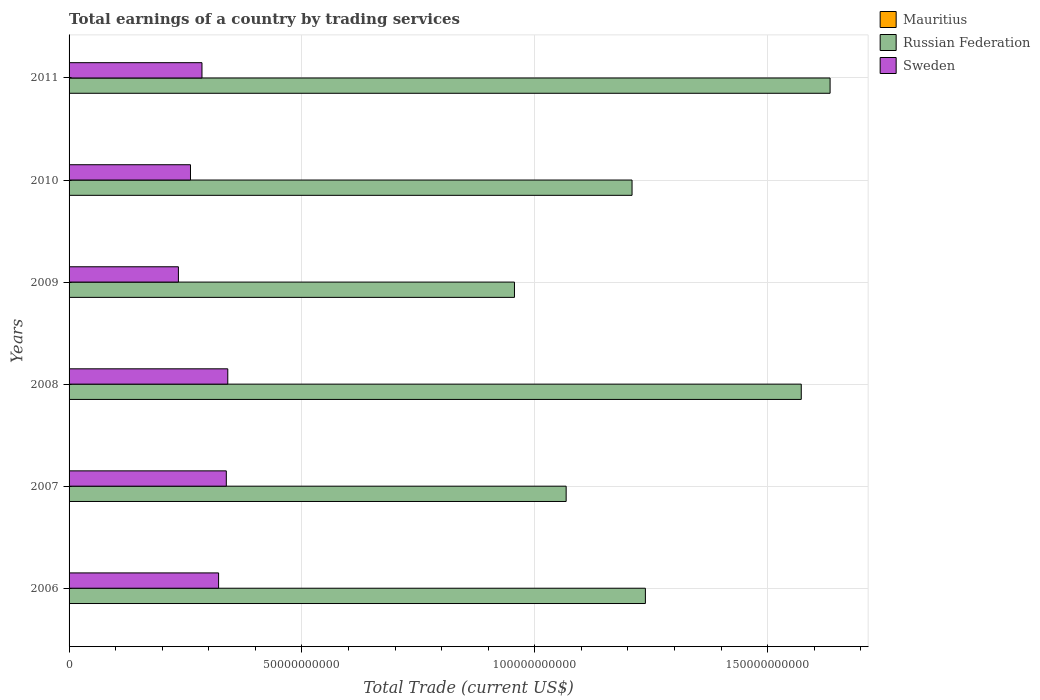How many bars are there on the 3rd tick from the top?
Your answer should be very brief. 2. What is the label of the 4th group of bars from the top?
Provide a succinct answer. 2008. What is the total earnings in Mauritius in 2006?
Make the answer very short. 0. Across all years, what is the maximum total earnings in Sweden?
Keep it short and to the point. 3.41e+1. Across all years, what is the minimum total earnings in Sweden?
Give a very brief answer. 2.35e+1. In which year was the total earnings in Russian Federation maximum?
Your response must be concise. 2011. What is the total total earnings in Mauritius in the graph?
Ensure brevity in your answer.  0. What is the difference between the total earnings in Russian Federation in 2008 and that in 2009?
Ensure brevity in your answer.  6.16e+1. What is the difference between the total earnings in Sweden in 2010 and the total earnings in Russian Federation in 2009?
Provide a short and direct response. -6.96e+1. What is the average total earnings in Sweden per year?
Offer a very short reply. 2.97e+1. In the year 2009, what is the difference between the total earnings in Sweden and total earnings in Russian Federation?
Your response must be concise. -7.22e+1. What is the ratio of the total earnings in Russian Federation in 2008 to that in 2010?
Provide a short and direct response. 1.3. What is the difference between the highest and the second highest total earnings in Sweden?
Your answer should be very brief. 3.17e+08. What is the difference between the highest and the lowest total earnings in Sweden?
Ensure brevity in your answer.  1.06e+1. How many bars are there?
Make the answer very short. 12. How many years are there in the graph?
Offer a terse response. 6. What is the difference between two consecutive major ticks on the X-axis?
Offer a very short reply. 5.00e+1. Are the values on the major ticks of X-axis written in scientific E-notation?
Your answer should be very brief. No. Does the graph contain any zero values?
Ensure brevity in your answer.  Yes. Does the graph contain grids?
Offer a terse response. Yes. What is the title of the graph?
Your answer should be very brief. Total earnings of a country by trading services. What is the label or title of the X-axis?
Your answer should be compact. Total Trade (current US$). What is the Total Trade (current US$) in Russian Federation in 2006?
Keep it short and to the point. 1.24e+11. What is the Total Trade (current US$) in Sweden in 2006?
Make the answer very short. 3.21e+1. What is the Total Trade (current US$) of Mauritius in 2007?
Your response must be concise. 0. What is the Total Trade (current US$) in Russian Federation in 2007?
Make the answer very short. 1.07e+11. What is the Total Trade (current US$) in Sweden in 2007?
Provide a short and direct response. 3.38e+1. What is the Total Trade (current US$) in Mauritius in 2008?
Provide a succinct answer. 0. What is the Total Trade (current US$) in Russian Federation in 2008?
Give a very brief answer. 1.57e+11. What is the Total Trade (current US$) in Sweden in 2008?
Provide a succinct answer. 3.41e+1. What is the Total Trade (current US$) of Russian Federation in 2009?
Give a very brief answer. 9.56e+1. What is the Total Trade (current US$) of Sweden in 2009?
Your response must be concise. 2.35e+1. What is the Total Trade (current US$) in Russian Federation in 2010?
Offer a terse response. 1.21e+11. What is the Total Trade (current US$) of Sweden in 2010?
Provide a succinct answer. 2.61e+1. What is the Total Trade (current US$) in Mauritius in 2011?
Your answer should be very brief. 0. What is the Total Trade (current US$) of Russian Federation in 2011?
Ensure brevity in your answer.  1.63e+11. What is the Total Trade (current US$) in Sweden in 2011?
Offer a very short reply. 2.85e+1. Across all years, what is the maximum Total Trade (current US$) of Russian Federation?
Your answer should be very brief. 1.63e+11. Across all years, what is the maximum Total Trade (current US$) of Sweden?
Give a very brief answer. 3.41e+1. Across all years, what is the minimum Total Trade (current US$) of Russian Federation?
Keep it short and to the point. 9.56e+1. Across all years, what is the minimum Total Trade (current US$) in Sweden?
Make the answer very short. 2.35e+1. What is the total Total Trade (current US$) in Russian Federation in the graph?
Provide a short and direct response. 7.68e+11. What is the total Total Trade (current US$) of Sweden in the graph?
Provide a succinct answer. 1.78e+11. What is the difference between the Total Trade (current US$) in Russian Federation in 2006 and that in 2007?
Keep it short and to the point. 1.70e+1. What is the difference between the Total Trade (current US$) in Sweden in 2006 and that in 2007?
Your answer should be very brief. -1.66e+09. What is the difference between the Total Trade (current US$) in Russian Federation in 2006 and that in 2008?
Your answer should be compact. -3.35e+1. What is the difference between the Total Trade (current US$) in Sweden in 2006 and that in 2008?
Make the answer very short. -1.97e+09. What is the difference between the Total Trade (current US$) of Russian Federation in 2006 and that in 2009?
Your response must be concise. 2.81e+1. What is the difference between the Total Trade (current US$) of Sweden in 2006 and that in 2009?
Your response must be concise. 8.63e+09. What is the difference between the Total Trade (current US$) of Russian Federation in 2006 and that in 2010?
Keep it short and to the point. 2.86e+09. What is the difference between the Total Trade (current US$) of Sweden in 2006 and that in 2010?
Your answer should be very brief. 6.04e+09. What is the difference between the Total Trade (current US$) of Russian Federation in 2006 and that in 2011?
Your answer should be very brief. -3.97e+1. What is the difference between the Total Trade (current US$) in Sweden in 2006 and that in 2011?
Keep it short and to the point. 3.57e+09. What is the difference between the Total Trade (current US$) in Russian Federation in 2007 and that in 2008?
Make the answer very short. -5.05e+1. What is the difference between the Total Trade (current US$) in Sweden in 2007 and that in 2008?
Provide a short and direct response. -3.17e+08. What is the difference between the Total Trade (current US$) of Russian Federation in 2007 and that in 2009?
Provide a short and direct response. 1.11e+1. What is the difference between the Total Trade (current US$) in Sweden in 2007 and that in 2009?
Your response must be concise. 1.03e+1. What is the difference between the Total Trade (current US$) of Russian Federation in 2007 and that in 2010?
Give a very brief answer. -1.41e+1. What is the difference between the Total Trade (current US$) in Sweden in 2007 and that in 2010?
Provide a short and direct response. 7.69e+09. What is the difference between the Total Trade (current US$) in Russian Federation in 2007 and that in 2011?
Your response must be concise. -5.67e+1. What is the difference between the Total Trade (current US$) in Sweden in 2007 and that in 2011?
Provide a succinct answer. 5.23e+09. What is the difference between the Total Trade (current US$) of Russian Federation in 2008 and that in 2009?
Your answer should be very brief. 6.16e+1. What is the difference between the Total Trade (current US$) of Sweden in 2008 and that in 2009?
Your answer should be compact. 1.06e+1. What is the difference between the Total Trade (current US$) in Russian Federation in 2008 and that in 2010?
Provide a short and direct response. 3.63e+1. What is the difference between the Total Trade (current US$) in Sweden in 2008 and that in 2010?
Keep it short and to the point. 8.01e+09. What is the difference between the Total Trade (current US$) of Russian Federation in 2008 and that in 2011?
Ensure brevity in your answer.  -6.19e+09. What is the difference between the Total Trade (current US$) of Sweden in 2008 and that in 2011?
Keep it short and to the point. 5.54e+09. What is the difference between the Total Trade (current US$) of Russian Federation in 2009 and that in 2010?
Provide a short and direct response. -2.52e+1. What is the difference between the Total Trade (current US$) in Sweden in 2009 and that in 2010?
Your response must be concise. -2.59e+09. What is the difference between the Total Trade (current US$) in Russian Federation in 2009 and that in 2011?
Your response must be concise. -6.78e+1. What is the difference between the Total Trade (current US$) of Sweden in 2009 and that in 2011?
Your answer should be very brief. -5.06e+09. What is the difference between the Total Trade (current US$) in Russian Federation in 2010 and that in 2011?
Your answer should be compact. -4.25e+1. What is the difference between the Total Trade (current US$) of Sweden in 2010 and that in 2011?
Offer a terse response. -2.47e+09. What is the difference between the Total Trade (current US$) in Russian Federation in 2006 and the Total Trade (current US$) in Sweden in 2007?
Your answer should be very brief. 9.00e+1. What is the difference between the Total Trade (current US$) of Russian Federation in 2006 and the Total Trade (current US$) of Sweden in 2008?
Ensure brevity in your answer.  8.97e+1. What is the difference between the Total Trade (current US$) of Russian Federation in 2006 and the Total Trade (current US$) of Sweden in 2009?
Provide a succinct answer. 1.00e+11. What is the difference between the Total Trade (current US$) of Russian Federation in 2006 and the Total Trade (current US$) of Sweden in 2010?
Your answer should be compact. 9.77e+1. What is the difference between the Total Trade (current US$) of Russian Federation in 2006 and the Total Trade (current US$) of Sweden in 2011?
Keep it short and to the point. 9.52e+1. What is the difference between the Total Trade (current US$) of Russian Federation in 2007 and the Total Trade (current US$) of Sweden in 2008?
Provide a succinct answer. 7.27e+1. What is the difference between the Total Trade (current US$) of Russian Federation in 2007 and the Total Trade (current US$) of Sweden in 2009?
Provide a short and direct response. 8.33e+1. What is the difference between the Total Trade (current US$) in Russian Federation in 2007 and the Total Trade (current US$) in Sweden in 2010?
Your answer should be very brief. 8.07e+1. What is the difference between the Total Trade (current US$) in Russian Federation in 2007 and the Total Trade (current US$) in Sweden in 2011?
Your response must be concise. 7.82e+1. What is the difference between the Total Trade (current US$) in Russian Federation in 2008 and the Total Trade (current US$) in Sweden in 2009?
Your response must be concise. 1.34e+11. What is the difference between the Total Trade (current US$) of Russian Federation in 2008 and the Total Trade (current US$) of Sweden in 2010?
Your response must be concise. 1.31e+11. What is the difference between the Total Trade (current US$) of Russian Federation in 2008 and the Total Trade (current US$) of Sweden in 2011?
Your response must be concise. 1.29e+11. What is the difference between the Total Trade (current US$) in Russian Federation in 2009 and the Total Trade (current US$) in Sweden in 2010?
Your answer should be compact. 6.96e+1. What is the difference between the Total Trade (current US$) in Russian Federation in 2009 and the Total Trade (current US$) in Sweden in 2011?
Ensure brevity in your answer.  6.71e+1. What is the difference between the Total Trade (current US$) in Russian Federation in 2010 and the Total Trade (current US$) in Sweden in 2011?
Ensure brevity in your answer.  9.23e+1. What is the average Total Trade (current US$) in Russian Federation per year?
Provide a succinct answer. 1.28e+11. What is the average Total Trade (current US$) of Sweden per year?
Keep it short and to the point. 2.97e+1. In the year 2006, what is the difference between the Total Trade (current US$) in Russian Federation and Total Trade (current US$) in Sweden?
Offer a very short reply. 9.16e+1. In the year 2007, what is the difference between the Total Trade (current US$) in Russian Federation and Total Trade (current US$) in Sweden?
Ensure brevity in your answer.  7.30e+1. In the year 2008, what is the difference between the Total Trade (current US$) in Russian Federation and Total Trade (current US$) in Sweden?
Your answer should be very brief. 1.23e+11. In the year 2009, what is the difference between the Total Trade (current US$) of Russian Federation and Total Trade (current US$) of Sweden?
Keep it short and to the point. 7.22e+1. In the year 2010, what is the difference between the Total Trade (current US$) in Russian Federation and Total Trade (current US$) in Sweden?
Your answer should be very brief. 9.48e+1. In the year 2011, what is the difference between the Total Trade (current US$) of Russian Federation and Total Trade (current US$) of Sweden?
Provide a short and direct response. 1.35e+11. What is the ratio of the Total Trade (current US$) in Russian Federation in 2006 to that in 2007?
Your response must be concise. 1.16. What is the ratio of the Total Trade (current US$) of Sweden in 2006 to that in 2007?
Your response must be concise. 0.95. What is the ratio of the Total Trade (current US$) in Russian Federation in 2006 to that in 2008?
Provide a short and direct response. 0.79. What is the ratio of the Total Trade (current US$) in Sweden in 2006 to that in 2008?
Your answer should be very brief. 0.94. What is the ratio of the Total Trade (current US$) of Russian Federation in 2006 to that in 2009?
Offer a terse response. 1.29. What is the ratio of the Total Trade (current US$) of Sweden in 2006 to that in 2009?
Offer a terse response. 1.37. What is the ratio of the Total Trade (current US$) of Russian Federation in 2006 to that in 2010?
Keep it short and to the point. 1.02. What is the ratio of the Total Trade (current US$) of Sweden in 2006 to that in 2010?
Give a very brief answer. 1.23. What is the ratio of the Total Trade (current US$) in Russian Federation in 2006 to that in 2011?
Offer a very short reply. 0.76. What is the ratio of the Total Trade (current US$) in Sweden in 2006 to that in 2011?
Give a very brief answer. 1.13. What is the ratio of the Total Trade (current US$) of Russian Federation in 2007 to that in 2008?
Provide a short and direct response. 0.68. What is the ratio of the Total Trade (current US$) of Russian Federation in 2007 to that in 2009?
Provide a short and direct response. 1.12. What is the ratio of the Total Trade (current US$) in Sweden in 2007 to that in 2009?
Your answer should be compact. 1.44. What is the ratio of the Total Trade (current US$) in Russian Federation in 2007 to that in 2010?
Offer a very short reply. 0.88. What is the ratio of the Total Trade (current US$) in Sweden in 2007 to that in 2010?
Offer a very short reply. 1.3. What is the ratio of the Total Trade (current US$) of Russian Federation in 2007 to that in 2011?
Keep it short and to the point. 0.65. What is the ratio of the Total Trade (current US$) in Sweden in 2007 to that in 2011?
Offer a terse response. 1.18. What is the ratio of the Total Trade (current US$) in Russian Federation in 2008 to that in 2009?
Provide a succinct answer. 1.64. What is the ratio of the Total Trade (current US$) of Sweden in 2008 to that in 2009?
Provide a short and direct response. 1.45. What is the ratio of the Total Trade (current US$) in Russian Federation in 2008 to that in 2010?
Offer a terse response. 1.3. What is the ratio of the Total Trade (current US$) of Sweden in 2008 to that in 2010?
Keep it short and to the point. 1.31. What is the ratio of the Total Trade (current US$) in Russian Federation in 2008 to that in 2011?
Your answer should be compact. 0.96. What is the ratio of the Total Trade (current US$) in Sweden in 2008 to that in 2011?
Give a very brief answer. 1.19. What is the ratio of the Total Trade (current US$) in Russian Federation in 2009 to that in 2010?
Provide a short and direct response. 0.79. What is the ratio of the Total Trade (current US$) of Sweden in 2009 to that in 2010?
Your response must be concise. 0.9. What is the ratio of the Total Trade (current US$) in Russian Federation in 2009 to that in 2011?
Offer a very short reply. 0.59. What is the ratio of the Total Trade (current US$) in Sweden in 2009 to that in 2011?
Your answer should be very brief. 0.82. What is the ratio of the Total Trade (current US$) in Russian Federation in 2010 to that in 2011?
Give a very brief answer. 0.74. What is the ratio of the Total Trade (current US$) in Sweden in 2010 to that in 2011?
Keep it short and to the point. 0.91. What is the difference between the highest and the second highest Total Trade (current US$) in Russian Federation?
Offer a terse response. 6.19e+09. What is the difference between the highest and the second highest Total Trade (current US$) in Sweden?
Your response must be concise. 3.17e+08. What is the difference between the highest and the lowest Total Trade (current US$) of Russian Federation?
Provide a short and direct response. 6.78e+1. What is the difference between the highest and the lowest Total Trade (current US$) of Sweden?
Provide a short and direct response. 1.06e+1. 